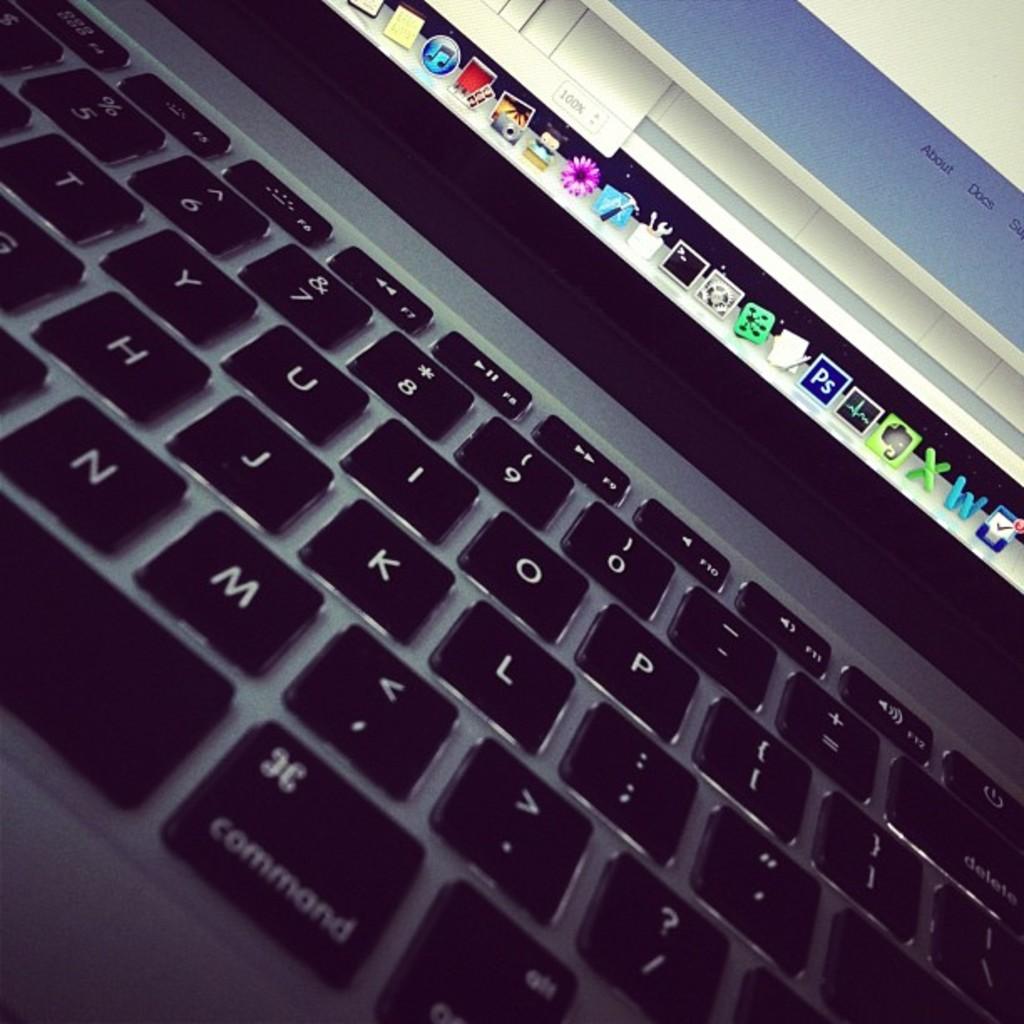What's the colour of the letters on the keyboard?
Your answer should be compact. Answering does not require reading text in the image. What word is to the left of docs on the screen?
Make the answer very short. About. 